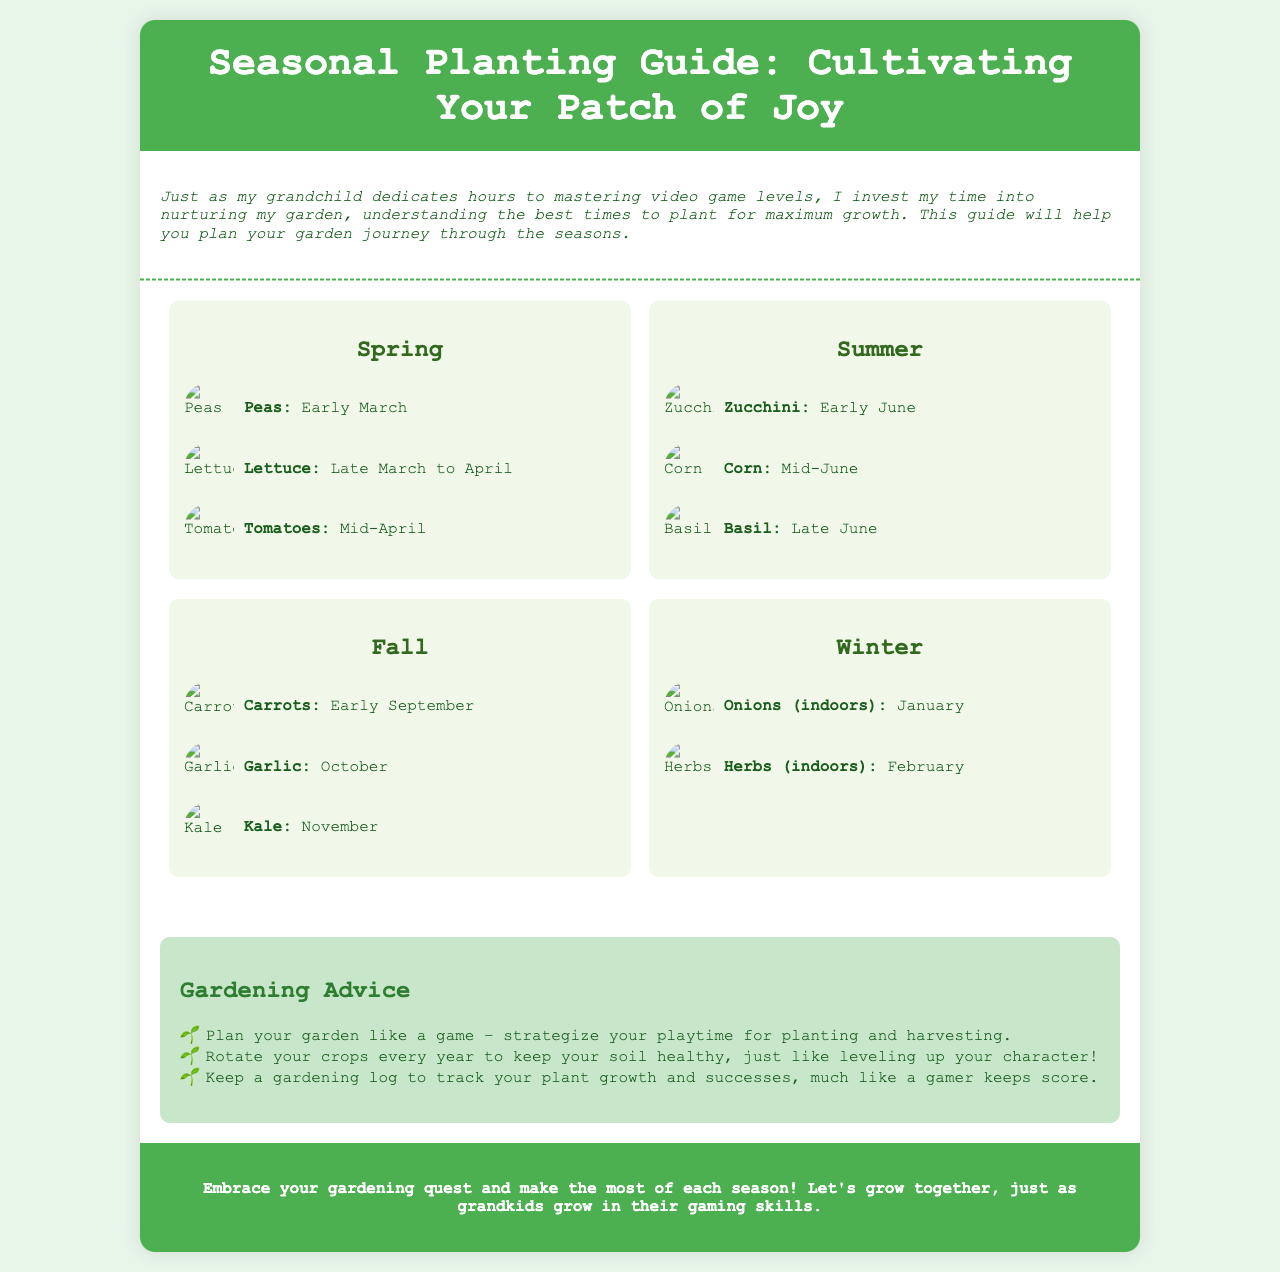What crops are recommended for early March planting? The document mentions "Peas" as the crop recommended for early March planting.
Answer: Peas When should lettuce be planted? According to the brochure, lettuce should be planted from late March to April.
Answer: Late March to April What is a gardening advice related to planning? The document suggests to "Plan your garden like a game – strategize your playtime for planting and harvesting."
Answer: Plan your garden like a game Which season features garlic planting? Garlic is specifically mentioned for planting in October, which falls under the Fall season.
Answer: Fall What is the main theme of the introduction? The introduction draws a parallel between gardening dedication and a grandchild's gaming dedication, emphasizing time investment.
Answer: Parallels between gardening and gaming dedication What time of year should carrots be planted? The document clearly states that carrots are to be planted in early September.
Answer: Early September 